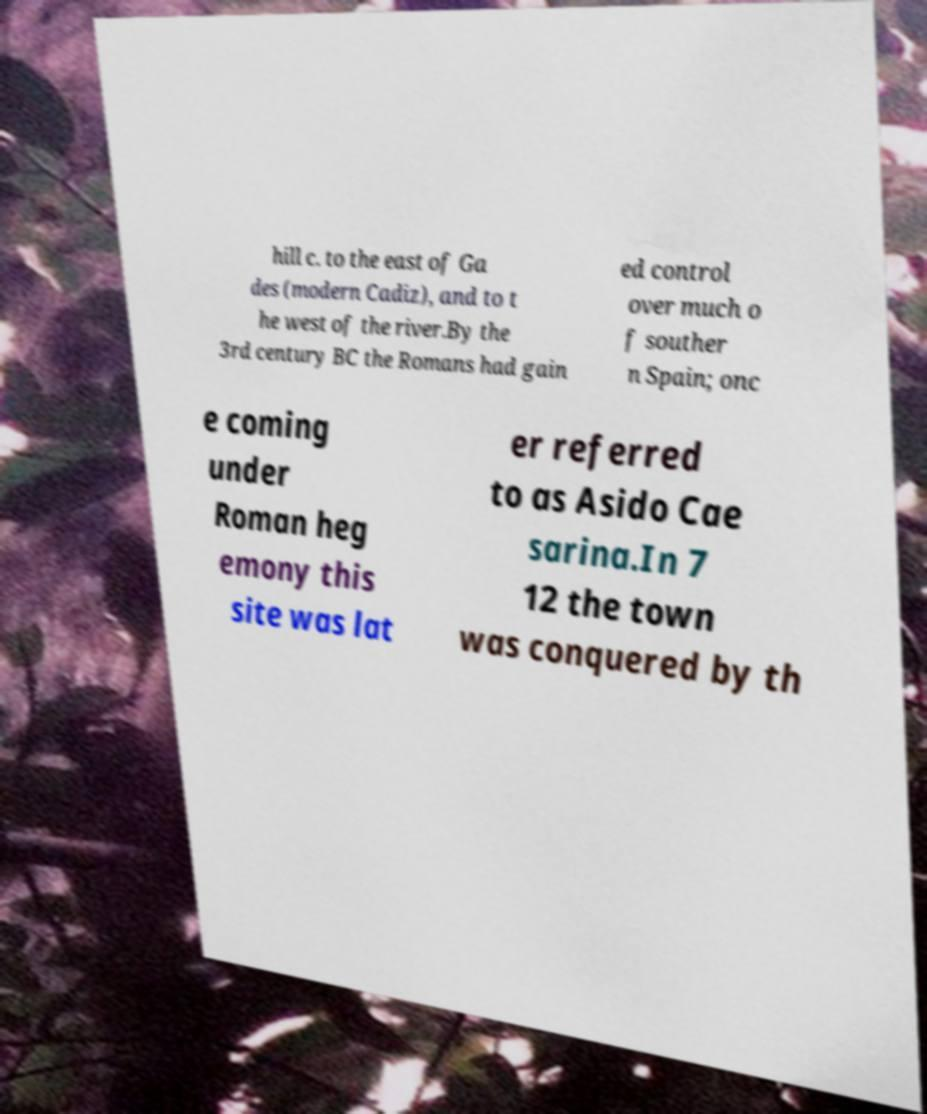What messages or text are displayed in this image? I need them in a readable, typed format. hill c. to the east of Ga des (modern Cadiz), and to t he west of the river.By the 3rd century BC the Romans had gain ed control over much o f souther n Spain; onc e coming under Roman heg emony this site was lat er referred to as Asido Cae sarina.In 7 12 the town was conquered by th 